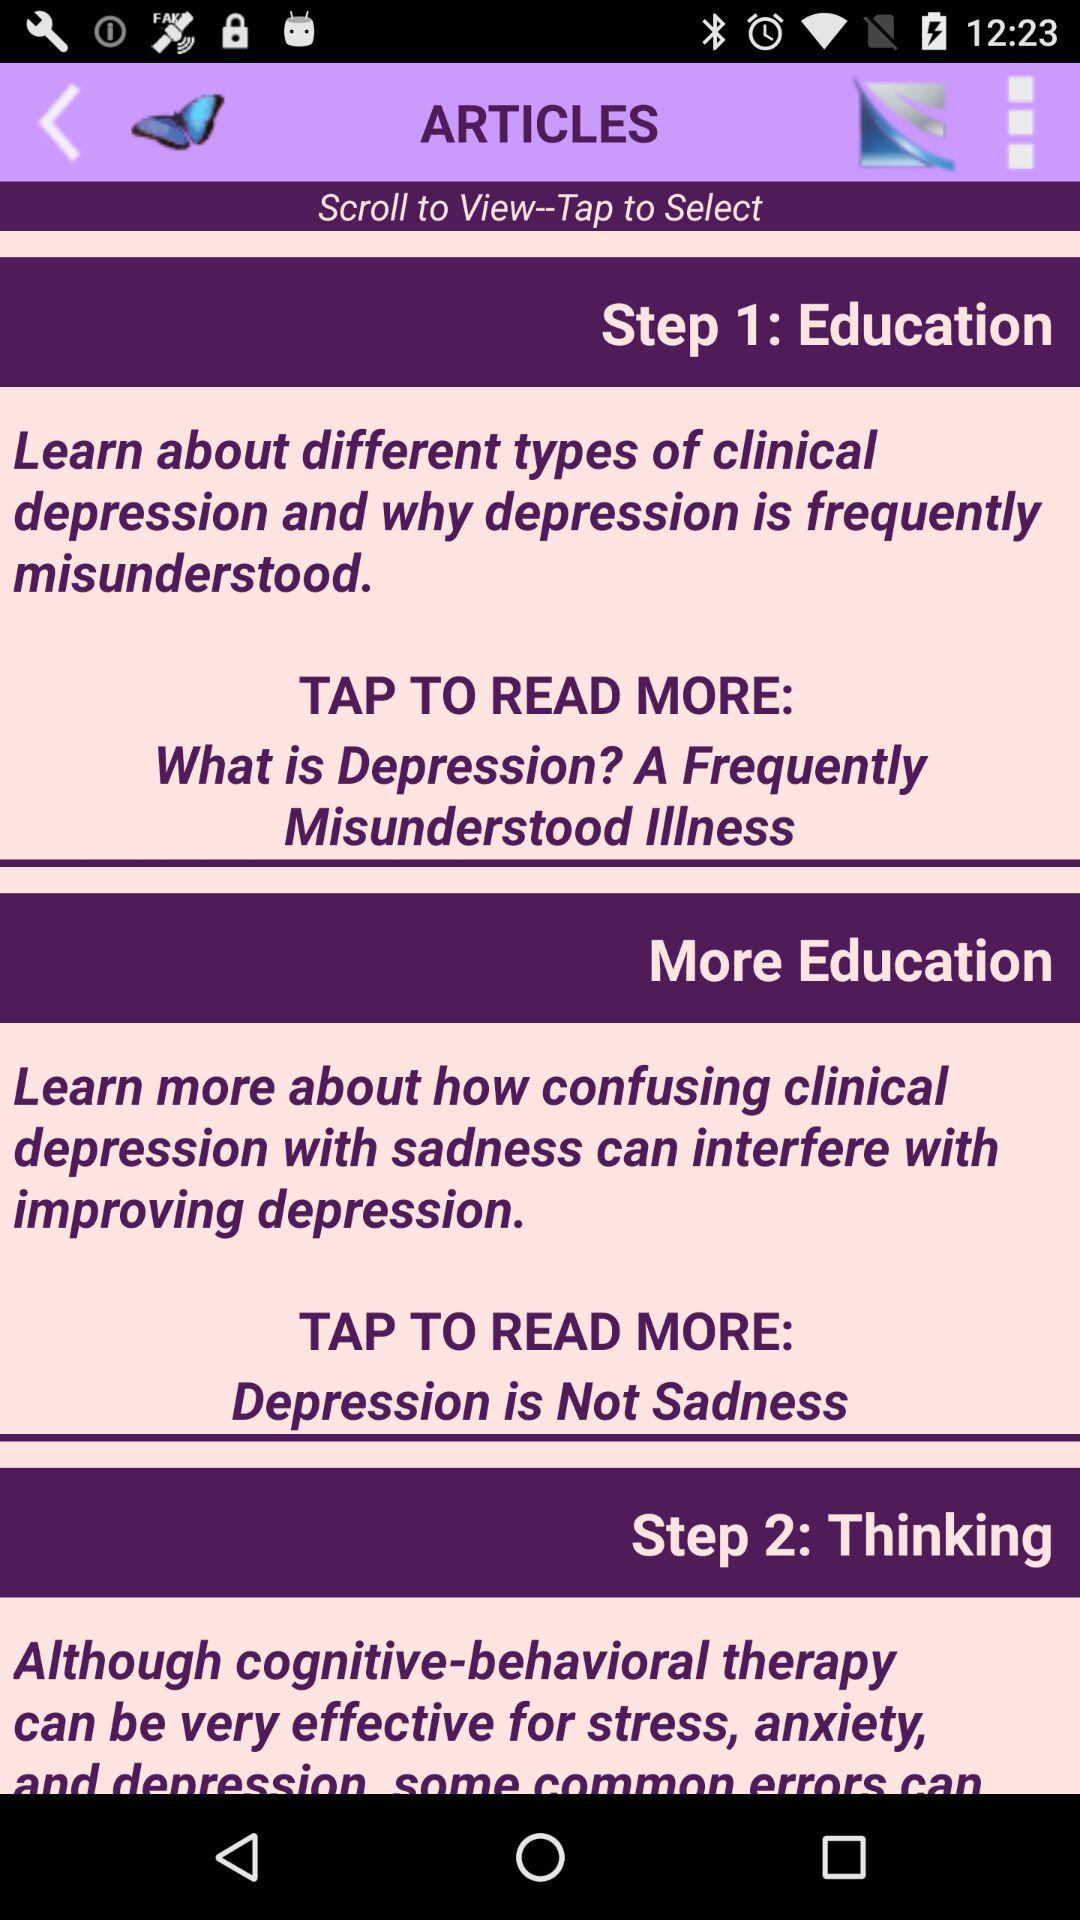How many steps are included in the treatment plan?
Answer the question using a single word or phrase. 2 